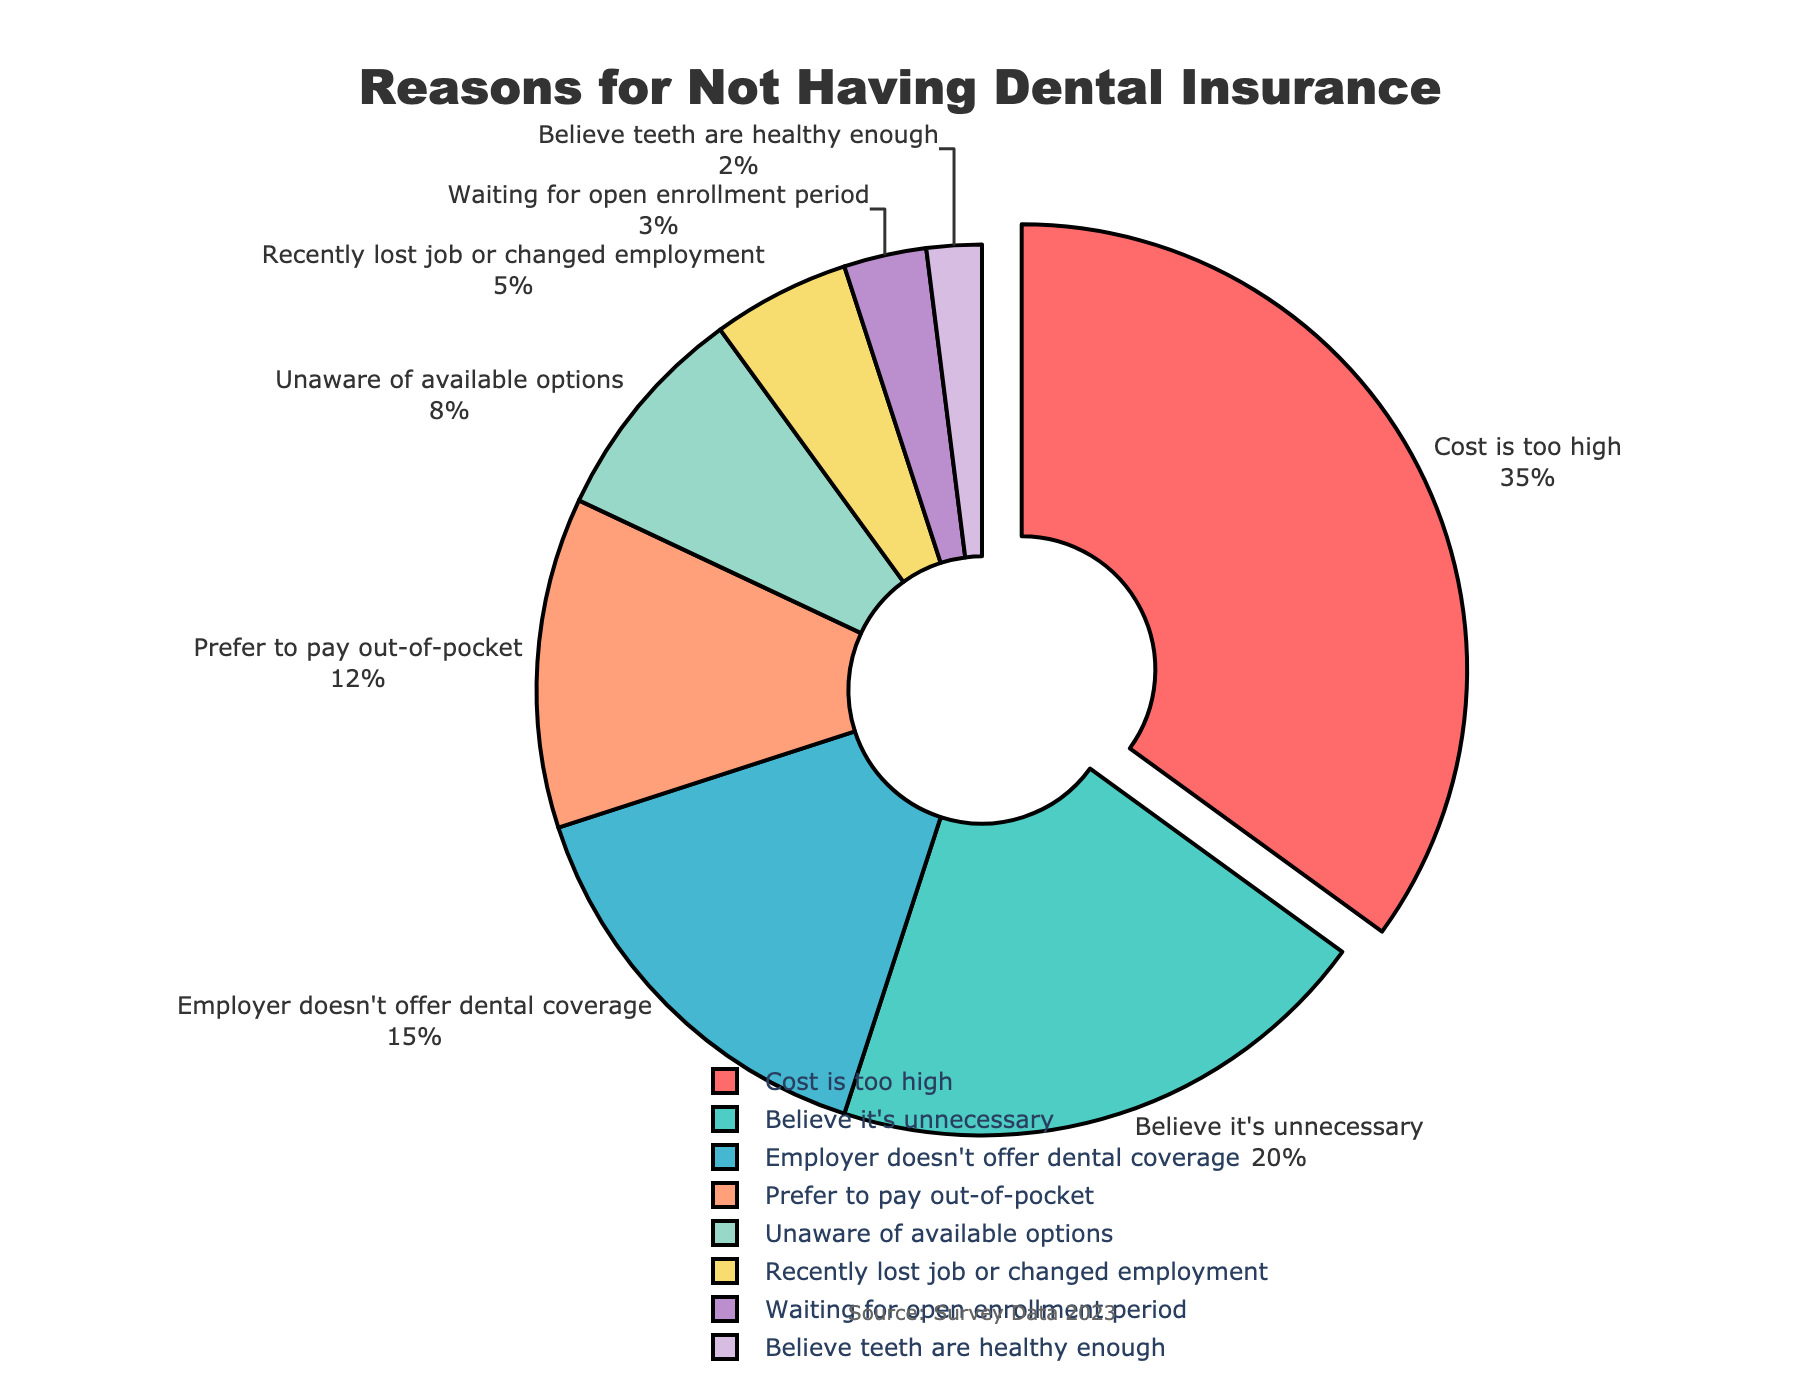What is the most common reason for not having dental insurance? The most common reason can be identified by looking at the segment with the highest percentage. The largest segment is labeled "Cost is too high", which has a percentage of 35%.
Answer: Cost is too high What percentage of individuals believe dental insurance is unnecessary? To find this, locate the segment labeled "Believe it's unnecessary" and refer to its corresponding percentage value, which is 20%.
Answer: 20% How much more common is the reason "Cost is too high" compared to "Employer doesn't offer dental coverage"? To find the difference, subtract the percentage of "Employer doesn't offer dental coverage" (15%) from "Cost is too high" (35%): 35% - 15% = 20%.
Answer: 20% Which reason has the smallest percentage of individuals citing it? Look for the segment with the smallest percentage value. The smallest value is 2%, labeled "Believe teeth are healthy enough".
Answer: Believe teeth are healthy enough What is the combined percentage of individuals who either "Prefer to pay out-of-pocket" or are "Unaware of available options"? Sum the percentages of both segments: "Prefer to pay out-of-pocket" (12%) + "Unaware of available options" (8%) = 12% + 8% = 20%.
Answer: 20% Is "Unaware of available options" more or less common than "Employer doesn't offer dental coverage"? Compare the percentages of the two reasons. "Unaware of available options" has 8%, and "Employer doesn't offer dental coverage" has 15%. Therefore, it is less common.
Answer: Less common What is the total percentage for reasons related to employment (employer doesn't offer dental coverage, recently lost job or changed employment, and waiting for open enrollment period)? Add the percentages of the relevant segments: "Employer doesn't offer dental coverage" (15%) + "Recently lost job or changed employment" (5%) + "Waiting for open enrollment period" (3%) = 15% + 5% + 3% = 23%.
Answer: 23% What visual feature distinguishes the reason with the highest percentage from other reasons? The largest segment, representing "Cost is too high," is pulled out slightly from the pie chart, distinguishing it visually from the other segments.
Answer: Pulled out slightly How does the percentage of individuals who "Believe it's unnecessary" compare to those who "Prefer to pay out-of-pocket"? Compare the percentages: "Believe it's unnecessary" is at 20%, while "Prefer to pay out-of-pocket" is at 12%. Therefore, "Believe it's unnecessary" is more common.
Answer: More common 